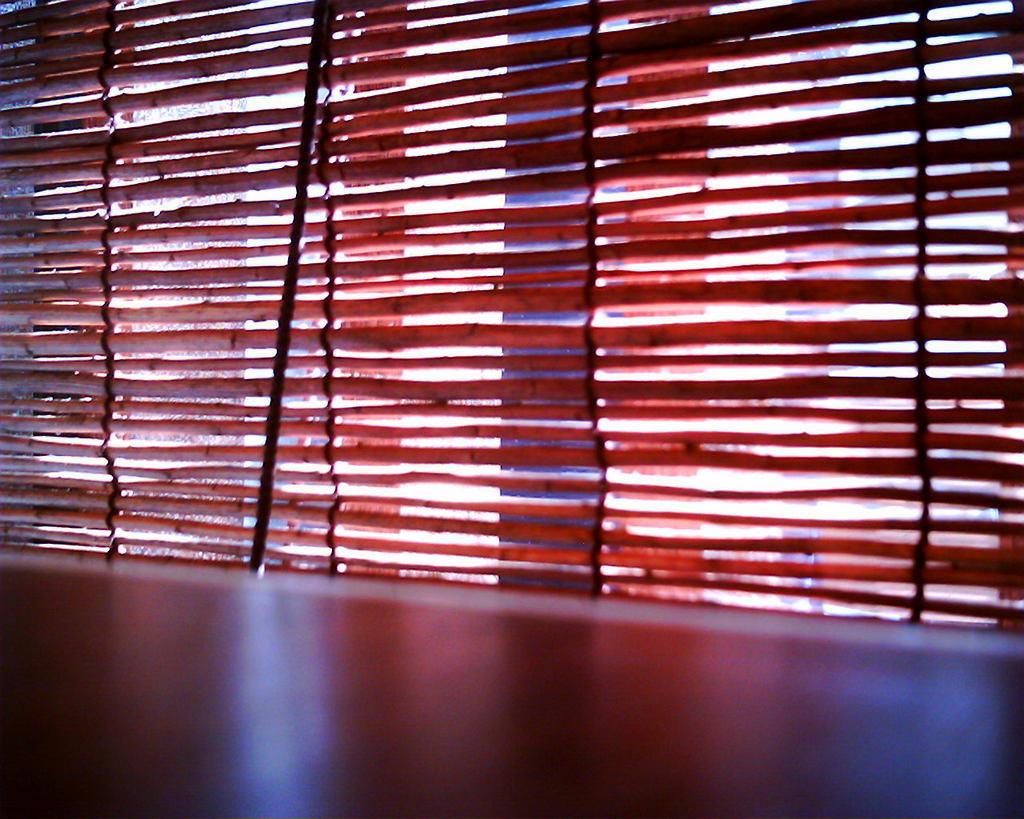What is a prominent feature in the image? There is a wall in the image. What type of window treatment is present in the image? There is a bamboo curtain on a window in the image. How does the image contribute to reducing pollution? The image itself does not contribute to reducing pollution; it is a static representation. 